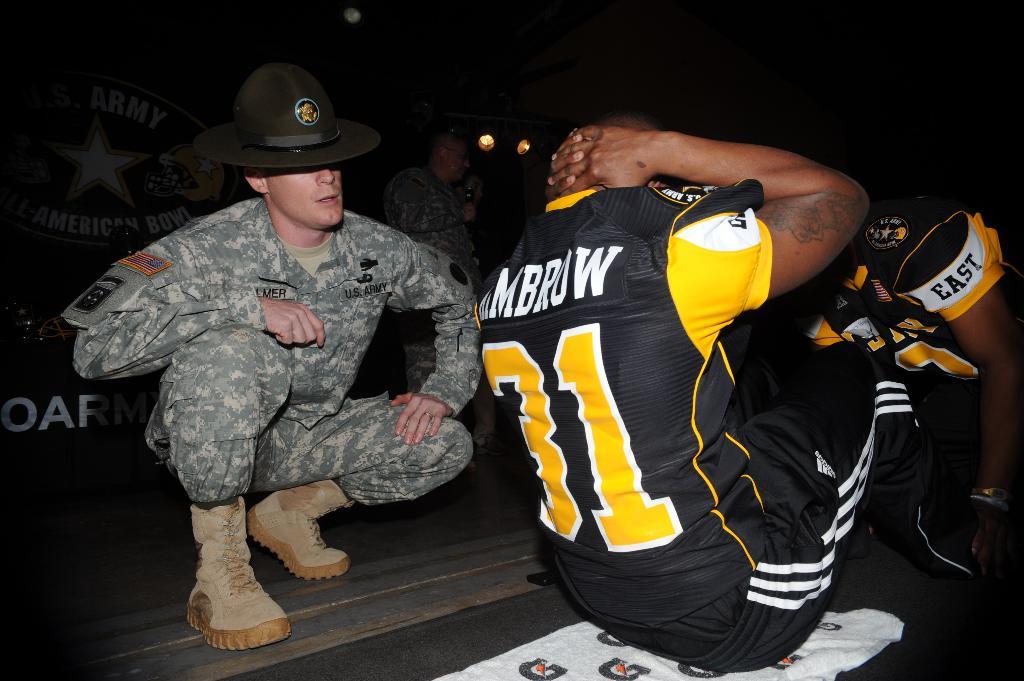What is written on the leg band?
Provide a short and direct response. East. What number is on his jersey?
Keep it short and to the point. 31. 